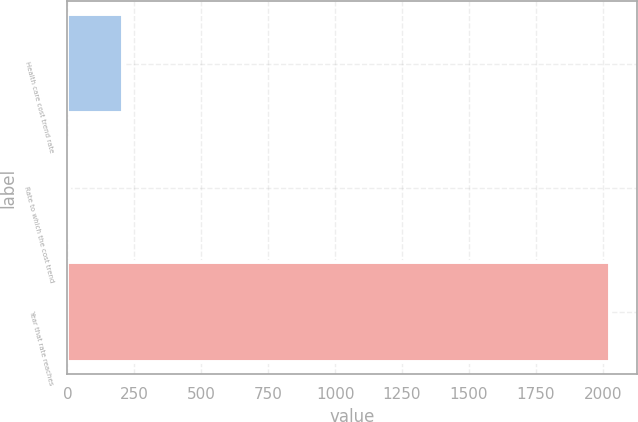<chart> <loc_0><loc_0><loc_500><loc_500><bar_chart><fcel>Health care cost trend rate<fcel>Rate to which the cost trend<fcel>Year that rate reaches<nl><fcel>206.75<fcel>4.5<fcel>2027<nl></chart> 